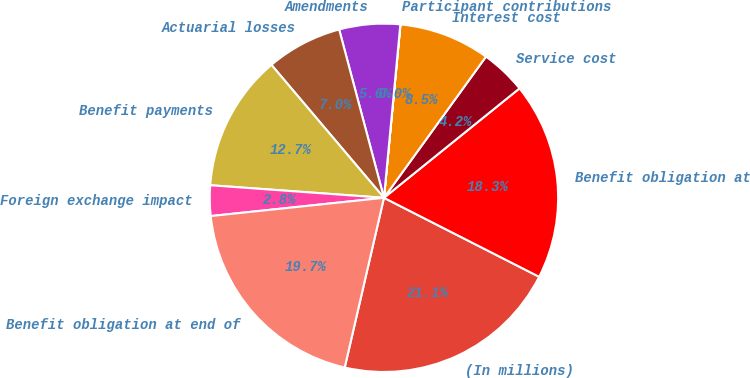<chart> <loc_0><loc_0><loc_500><loc_500><pie_chart><fcel>(In millions)<fcel>Benefit obligation at<fcel>Service cost<fcel>Interest cost<fcel>Participant contributions<fcel>Amendments<fcel>Actuarial losses<fcel>Benefit payments<fcel>Foreign exchange impact<fcel>Benefit obligation at end of<nl><fcel>21.12%<fcel>18.3%<fcel>4.23%<fcel>8.45%<fcel>0.01%<fcel>5.64%<fcel>7.04%<fcel>12.67%<fcel>2.82%<fcel>19.71%<nl></chart> 